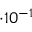Convert formula to latex. <formula><loc_0><loc_0><loc_500><loc_500>\cdot 1 0 ^ { - 1 }</formula> 